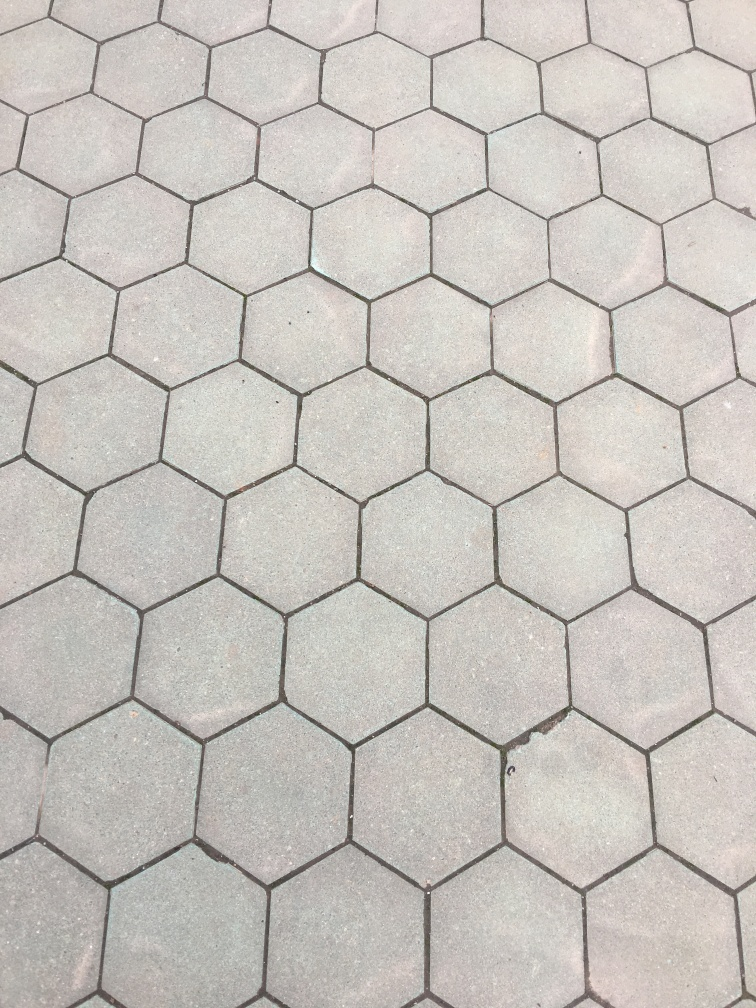How would you rate the quality of this image? Upon scrutiny, the image is of moderate quality. While it appears clear and well-lit, showing the hexagonal pattern of the pavement clearly, minor blemishes and a certain lack of sharpness prevent it from being classified as excellent. 